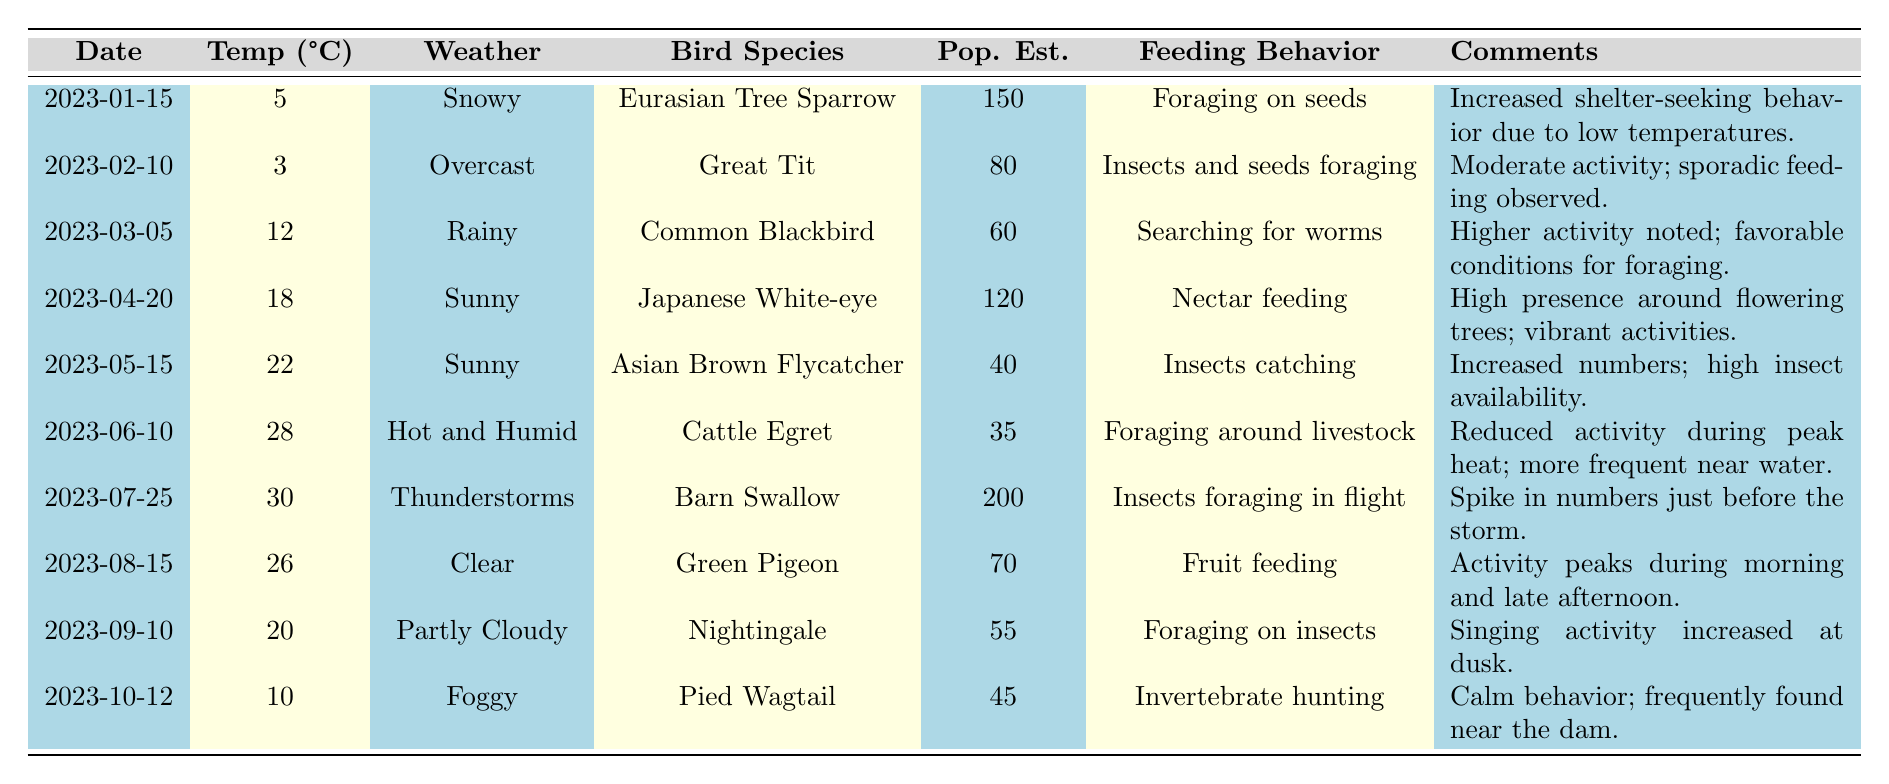What was the highest bird population observed around the Tamiyasu Dam? The highest population estimate in the table is 200, which corresponds to the Barn Swallow on July 25, 2023.
Answer: 200 On which date did the Asian Brown Flycatcher have the lowest estimated population? The table shows that the lowest population estimate for the Asian Brown Flycatcher was 40 on May 15, 2023.
Answer: May 15, 2023 How many bird species were observed in sunny weather conditions? The table indicates that two species were observed under sunny conditions: Japanese White-eye and Asian Brown Flycatcher.
Answer: 2 What is the average temperature for the months of March, April, and May? The temperatures recorded for those months are 12 (March), 18 (April), and 22 (May). The average is (12 + 18 + 22) / 3 = 52 / 3 = 17.33.
Answer: 17.33 Did the population of Cattle Egret increase or decrease as the temperature increased? The Cattle Egret had a population estimate of 35 at 28°C, which is lower than the earlier observed species, suggesting a decrease as temperature rises compared to previous conditions.
Answer: Decrease How does the feeding behavior of birds differ on rainy versus sunny days? The birds' feeding behaviors showed differences: on rainy days (like March 5), they searched for worms, while on sunny days (like April 20), they engaged in nectar feeding and high activity around flowering trees.
Answer: Different behaviors What was the observed temperature during the thunderstorm event? According to the table, the temperature during the thunderstorm on July 25, 2023, was 30°C.
Answer: 30°C Which bird species had increased activity right before a weather event and what was the event? The Barn Swallow showed an increase in activity just before thunderstorms on July 25, 2023, with a population estimate of 200.
Answer: Barn Swallow, thunderstorms Between which two weather conditions was the largest difference in bird population estimates? Comparing the overcast condition with 80 (Great Tit) and thunderstorms with 200 (Barn Swallow), the difference is 200 - 80 = 120.
Answer: 120 Was the population of the Pied Wagtail affected by foggy weather? Yes, the Pied Wagtail had a lower population estimate of 45 during foggy conditions, indicating a possible impact due to the weather.
Answer: Yes 